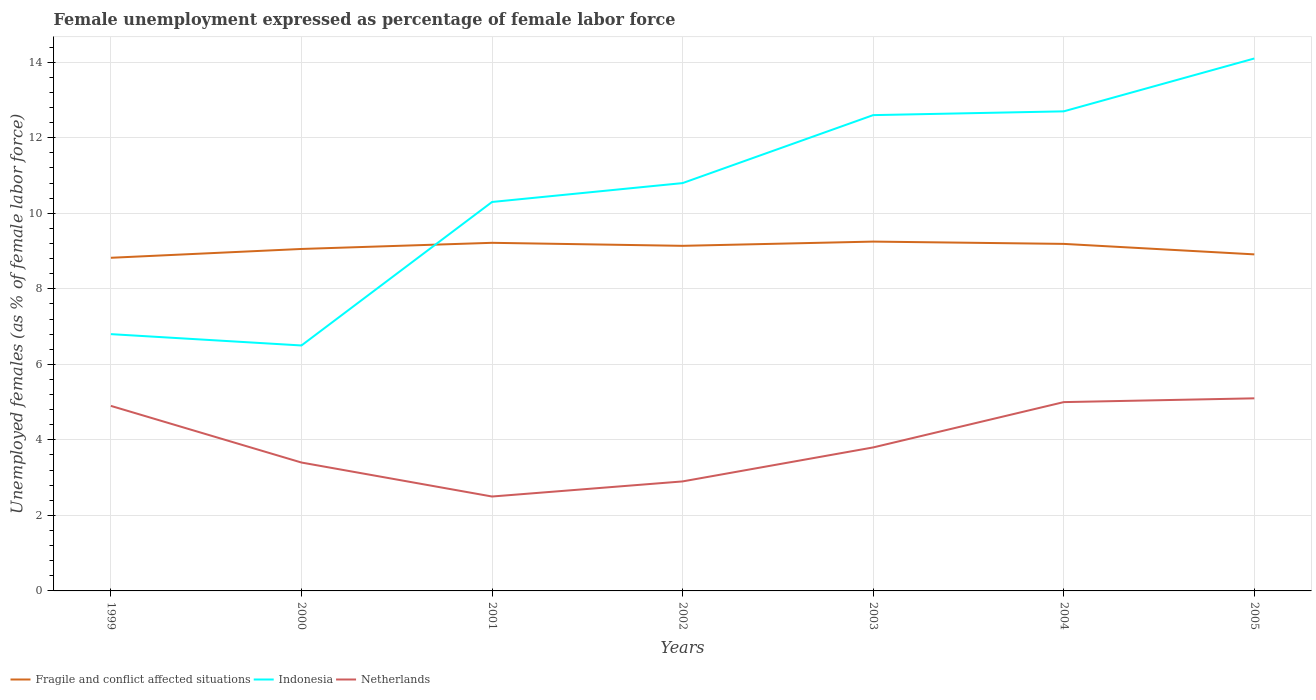How many different coloured lines are there?
Provide a short and direct response. 3. In which year was the unemployment in females in in Netherlands maximum?
Your answer should be compact. 2001. What is the total unemployment in females in in Netherlands in the graph?
Your answer should be compact. -1.3. What is the difference between the highest and the second highest unemployment in females in in Fragile and conflict affected situations?
Keep it short and to the point. 0.43. Is the unemployment in females in in Indonesia strictly greater than the unemployment in females in in Netherlands over the years?
Offer a terse response. No. How many lines are there?
Your answer should be compact. 3. How many years are there in the graph?
Ensure brevity in your answer.  7. What is the difference between two consecutive major ticks on the Y-axis?
Your answer should be compact. 2. Are the values on the major ticks of Y-axis written in scientific E-notation?
Ensure brevity in your answer.  No. Does the graph contain any zero values?
Keep it short and to the point. No. Does the graph contain grids?
Provide a short and direct response. Yes. Where does the legend appear in the graph?
Your response must be concise. Bottom left. How are the legend labels stacked?
Your response must be concise. Horizontal. What is the title of the graph?
Your answer should be very brief. Female unemployment expressed as percentage of female labor force. What is the label or title of the X-axis?
Give a very brief answer. Years. What is the label or title of the Y-axis?
Your answer should be very brief. Unemployed females (as % of female labor force). What is the Unemployed females (as % of female labor force) of Fragile and conflict affected situations in 1999?
Keep it short and to the point. 8.82. What is the Unemployed females (as % of female labor force) in Indonesia in 1999?
Offer a terse response. 6.8. What is the Unemployed females (as % of female labor force) of Netherlands in 1999?
Provide a succinct answer. 4.9. What is the Unemployed females (as % of female labor force) of Fragile and conflict affected situations in 2000?
Provide a short and direct response. 9.06. What is the Unemployed females (as % of female labor force) in Indonesia in 2000?
Offer a terse response. 6.5. What is the Unemployed females (as % of female labor force) of Netherlands in 2000?
Ensure brevity in your answer.  3.4. What is the Unemployed females (as % of female labor force) in Fragile and conflict affected situations in 2001?
Your answer should be compact. 9.22. What is the Unemployed females (as % of female labor force) of Indonesia in 2001?
Offer a terse response. 10.3. What is the Unemployed females (as % of female labor force) in Fragile and conflict affected situations in 2002?
Ensure brevity in your answer.  9.14. What is the Unemployed females (as % of female labor force) in Indonesia in 2002?
Keep it short and to the point. 10.8. What is the Unemployed females (as % of female labor force) of Netherlands in 2002?
Give a very brief answer. 2.9. What is the Unemployed females (as % of female labor force) of Fragile and conflict affected situations in 2003?
Offer a very short reply. 9.25. What is the Unemployed females (as % of female labor force) in Indonesia in 2003?
Keep it short and to the point. 12.6. What is the Unemployed females (as % of female labor force) in Netherlands in 2003?
Offer a very short reply. 3.8. What is the Unemployed females (as % of female labor force) in Fragile and conflict affected situations in 2004?
Make the answer very short. 9.19. What is the Unemployed females (as % of female labor force) of Indonesia in 2004?
Provide a short and direct response. 12.7. What is the Unemployed females (as % of female labor force) in Fragile and conflict affected situations in 2005?
Provide a succinct answer. 8.91. What is the Unemployed females (as % of female labor force) in Indonesia in 2005?
Make the answer very short. 14.1. What is the Unemployed females (as % of female labor force) of Netherlands in 2005?
Ensure brevity in your answer.  5.1. Across all years, what is the maximum Unemployed females (as % of female labor force) of Fragile and conflict affected situations?
Provide a succinct answer. 9.25. Across all years, what is the maximum Unemployed females (as % of female labor force) in Indonesia?
Give a very brief answer. 14.1. Across all years, what is the maximum Unemployed females (as % of female labor force) of Netherlands?
Ensure brevity in your answer.  5.1. Across all years, what is the minimum Unemployed females (as % of female labor force) of Fragile and conflict affected situations?
Offer a terse response. 8.82. Across all years, what is the minimum Unemployed females (as % of female labor force) in Indonesia?
Your answer should be very brief. 6.5. What is the total Unemployed females (as % of female labor force) in Fragile and conflict affected situations in the graph?
Offer a terse response. 63.59. What is the total Unemployed females (as % of female labor force) of Indonesia in the graph?
Make the answer very short. 73.8. What is the total Unemployed females (as % of female labor force) of Netherlands in the graph?
Your answer should be compact. 27.6. What is the difference between the Unemployed females (as % of female labor force) in Fragile and conflict affected situations in 1999 and that in 2000?
Your response must be concise. -0.23. What is the difference between the Unemployed females (as % of female labor force) of Indonesia in 1999 and that in 2000?
Provide a short and direct response. 0.3. What is the difference between the Unemployed females (as % of female labor force) of Netherlands in 1999 and that in 2000?
Keep it short and to the point. 1.5. What is the difference between the Unemployed females (as % of female labor force) in Fragile and conflict affected situations in 1999 and that in 2001?
Offer a very short reply. -0.4. What is the difference between the Unemployed females (as % of female labor force) of Fragile and conflict affected situations in 1999 and that in 2002?
Ensure brevity in your answer.  -0.32. What is the difference between the Unemployed females (as % of female labor force) of Fragile and conflict affected situations in 1999 and that in 2003?
Keep it short and to the point. -0.43. What is the difference between the Unemployed females (as % of female labor force) in Fragile and conflict affected situations in 1999 and that in 2004?
Make the answer very short. -0.37. What is the difference between the Unemployed females (as % of female labor force) of Indonesia in 1999 and that in 2004?
Your answer should be compact. -5.9. What is the difference between the Unemployed females (as % of female labor force) of Fragile and conflict affected situations in 1999 and that in 2005?
Provide a short and direct response. -0.09. What is the difference between the Unemployed females (as % of female labor force) in Indonesia in 1999 and that in 2005?
Give a very brief answer. -7.3. What is the difference between the Unemployed females (as % of female labor force) in Fragile and conflict affected situations in 2000 and that in 2001?
Your answer should be compact. -0.16. What is the difference between the Unemployed females (as % of female labor force) in Netherlands in 2000 and that in 2001?
Offer a terse response. 0.9. What is the difference between the Unemployed females (as % of female labor force) in Fragile and conflict affected situations in 2000 and that in 2002?
Offer a very short reply. -0.08. What is the difference between the Unemployed females (as % of female labor force) in Netherlands in 2000 and that in 2002?
Offer a terse response. 0.5. What is the difference between the Unemployed females (as % of female labor force) of Fragile and conflict affected situations in 2000 and that in 2003?
Offer a terse response. -0.2. What is the difference between the Unemployed females (as % of female labor force) of Indonesia in 2000 and that in 2003?
Ensure brevity in your answer.  -6.1. What is the difference between the Unemployed females (as % of female labor force) of Netherlands in 2000 and that in 2003?
Your response must be concise. -0.4. What is the difference between the Unemployed females (as % of female labor force) in Fragile and conflict affected situations in 2000 and that in 2004?
Keep it short and to the point. -0.13. What is the difference between the Unemployed females (as % of female labor force) in Netherlands in 2000 and that in 2004?
Your response must be concise. -1.6. What is the difference between the Unemployed females (as % of female labor force) in Fragile and conflict affected situations in 2000 and that in 2005?
Keep it short and to the point. 0.14. What is the difference between the Unemployed females (as % of female labor force) in Indonesia in 2000 and that in 2005?
Give a very brief answer. -7.6. What is the difference between the Unemployed females (as % of female labor force) of Netherlands in 2000 and that in 2005?
Your answer should be compact. -1.7. What is the difference between the Unemployed females (as % of female labor force) of Fragile and conflict affected situations in 2001 and that in 2002?
Offer a very short reply. 0.08. What is the difference between the Unemployed females (as % of female labor force) of Fragile and conflict affected situations in 2001 and that in 2003?
Ensure brevity in your answer.  -0.03. What is the difference between the Unemployed females (as % of female labor force) in Indonesia in 2001 and that in 2003?
Provide a short and direct response. -2.3. What is the difference between the Unemployed females (as % of female labor force) in Fragile and conflict affected situations in 2001 and that in 2004?
Your answer should be very brief. 0.03. What is the difference between the Unemployed females (as % of female labor force) in Netherlands in 2001 and that in 2004?
Provide a succinct answer. -2.5. What is the difference between the Unemployed females (as % of female labor force) in Fragile and conflict affected situations in 2001 and that in 2005?
Your answer should be very brief. 0.31. What is the difference between the Unemployed females (as % of female labor force) of Fragile and conflict affected situations in 2002 and that in 2003?
Ensure brevity in your answer.  -0.11. What is the difference between the Unemployed females (as % of female labor force) of Indonesia in 2002 and that in 2003?
Give a very brief answer. -1.8. What is the difference between the Unemployed females (as % of female labor force) in Netherlands in 2002 and that in 2003?
Your answer should be very brief. -0.9. What is the difference between the Unemployed females (as % of female labor force) in Fragile and conflict affected situations in 2002 and that in 2004?
Your answer should be compact. -0.05. What is the difference between the Unemployed females (as % of female labor force) of Fragile and conflict affected situations in 2002 and that in 2005?
Your answer should be compact. 0.23. What is the difference between the Unemployed females (as % of female labor force) of Fragile and conflict affected situations in 2003 and that in 2004?
Offer a very short reply. 0.06. What is the difference between the Unemployed females (as % of female labor force) of Indonesia in 2003 and that in 2004?
Your answer should be very brief. -0.1. What is the difference between the Unemployed females (as % of female labor force) in Netherlands in 2003 and that in 2004?
Provide a short and direct response. -1.2. What is the difference between the Unemployed females (as % of female labor force) of Fragile and conflict affected situations in 2003 and that in 2005?
Your answer should be compact. 0.34. What is the difference between the Unemployed females (as % of female labor force) in Indonesia in 2003 and that in 2005?
Keep it short and to the point. -1.5. What is the difference between the Unemployed females (as % of female labor force) in Netherlands in 2003 and that in 2005?
Offer a terse response. -1.3. What is the difference between the Unemployed females (as % of female labor force) of Fragile and conflict affected situations in 2004 and that in 2005?
Make the answer very short. 0.28. What is the difference between the Unemployed females (as % of female labor force) in Indonesia in 2004 and that in 2005?
Provide a succinct answer. -1.4. What is the difference between the Unemployed females (as % of female labor force) of Netherlands in 2004 and that in 2005?
Your answer should be very brief. -0.1. What is the difference between the Unemployed females (as % of female labor force) of Fragile and conflict affected situations in 1999 and the Unemployed females (as % of female labor force) of Indonesia in 2000?
Ensure brevity in your answer.  2.32. What is the difference between the Unemployed females (as % of female labor force) of Fragile and conflict affected situations in 1999 and the Unemployed females (as % of female labor force) of Netherlands in 2000?
Make the answer very short. 5.42. What is the difference between the Unemployed females (as % of female labor force) in Fragile and conflict affected situations in 1999 and the Unemployed females (as % of female labor force) in Indonesia in 2001?
Make the answer very short. -1.48. What is the difference between the Unemployed females (as % of female labor force) of Fragile and conflict affected situations in 1999 and the Unemployed females (as % of female labor force) of Netherlands in 2001?
Your answer should be very brief. 6.32. What is the difference between the Unemployed females (as % of female labor force) in Indonesia in 1999 and the Unemployed females (as % of female labor force) in Netherlands in 2001?
Give a very brief answer. 4.3. What is the difference between the Unemployed females (as % of female labor force) of Fragile and conflict affected situations in 1999 and the Unemployed females (as % of female labor force) of Indonesia in 2002?
Provide a succinct answer. -1.98. What is the difference between the Unemployed females (as % of female labor force) of Fragile and conflict affected situations in 1999 and the Unemployed females (as % of female labor force) of Netherlands in 2002?
Your response must be concise. 5.92. What is the difference between the Unemployed females (as % of female labor force) in Indonesia in 1999 and the Unemployed females (as % of female labor force) in Netherlands in 2002?
Offer a terse response. 3.9. What is the difference between the Unemployed females (as % of female labor force) in Fragile and conflict affected situations in 1999 and the Unemployed females (as % of female labor force) in Indonesia in 2003?
Your answer should be compact. -3.78. What is the difference between the Unemployed females (as % of female labor force) of Fragile and conflict affected situations in 1999 and the Unemployed females (as % of female labor force) of Netherlands in 2003?
Make the answer very short. 5.02. What is the difference between the Unemployed females (as % of female labor force) in Indonesia in 1999 and the Unemployed females (as % of female labor force) in Netherlands in 2003?
Offer a terse response. 3. What is the difference between the Unemployed females (as % of female labor force) of Fragile and conflict affected situations in 1999 and the Unemployed females (as % of female labor force) of Indonesia in 2004?
Offer a terse response. -3.88. What is the difference between the Unemployed females (as % of female labor force) of Fragile and conflict affected situations in 1999 and the Unemployed females (as % of female labor force) of Netherlands in 2004?
Keep it short and to the point. 3.82. What is the difference between the Unemployed females (as % of female labor force) in Indonesia in 1999 and the Unemployed females (as % of female labor force) in Netherlands in 2004?
Give a very brief answer. 1.8. What is the difference between the Unemployed females (as % of female labor force) of Fragile and conflict affected situations in 1999 and the Unemployed females (as % of female labor force) of Indonesia in 2005?
Keep it short and to the point. -5.28. What is the difference between the Unemployed females (as % of female labor force) of Fragile and conflict affected situations in 1999 and the Unemployed females (as % of female labor force) of Netherlands in 2005?
Your answer should be very brief. 3.72. What is the difference between the Unemployed females (as % of female labor force) of Fragile and conflict affected situations in 2000 and the Unemployed females (as % of female labor force) of Indonesia in 2001?
Offer a very short reply. -1.24. What is the difference between the Unemployed females (as % of female labor force) in Fragile and conflict affected situations in 2000 and the Unemployed females (as % of female labor force) in Netherlands in 2001?
Offer a very short reply. 6.56. What is the difference between the Unemployed females (as % of female labor force) of Indonesia in 2000 and the Unemployed females (as % of female labor force) of Netherlands in 2001?
Your response must be concise. 4. What is the difference between the Unemployed females (as % of female labor force) in Fragile and conflict affected situations in 2000 and the Unemployed females (as % of female labor force) in Indonesia in 2002?
Give a very brief answer. -1.74. What is the difference between the Unemployed females (as % of female labor force) of Fragile and conflict affected situations in 2000 and the Unemployed females (as % of female labor force) of Netherlands in 2002?
Provide a short and direct response. 6.16. What is the difference between the Unemployed females (as % of female labor force) of Fragile and conflict affected situations in 2000 and the Unemployed females (as % of female labor force) of Indonesia in 2003?
Your answer should be very brief. -3.54. What is the difference between the Unemployed females (as % of female labor force) in Fragile and conflict affected situations in 2000 and the Unemployed females (as % of female labor force) in Netherlands in 2003?
Give a very brief answer. 5.26. What is the difference between the Unemployed females (as % of female labor force) in Indonesia in 2000 and the Unemployed females (as % of female labor force) in Netherlands in 2003?
Keep it short and to the point. 2.7. What is the difference between the Unemployed females (as % of female labor force) of Fragile and conflict affected situations in 2000 and the Unemployed females (as % of female labor force) of Indonesia in 2004?
Your answer should be very brief. -3.64. What is the difference between the Unemployed females (as % of female labor force) of Fragile and conflict affected situations in 2000 and the Unemployed females (as % of female labor force) of Netherlands in 2004?
Your answer should be compact. 4.06. What is the difference between the Unemployed females (as % of female labor force) in Indonesia in 2000 and the Unemployed females (as % of female labor force) in Netherlands in 2004?
Provide a short and direct response. 1.5. What is the difference between the Unemployed females (as % of female labor force) in Fragile and conflict affected situations in 2000 and the Unemployed females (as % of female labor force) in Indonesia in 2005?
Ensure brevity in your answer.  -5.04. What is the difference between the Unemployed females (as % of female labor force) in Fragile and conflict affected situations in 2000 and the Unemployed females (as % of female labor force) in Netherlands in 2005?
Your response must be concise. 3.96. What is the difference between the Unemployed females (as % of female labor force) in Indonesia in 2000 and the Unemployed females (as % of female labor force) in Netherlands in 2005?
Provide a short and direct response. 1.4. What is the difference between the Unemployed females (as % of female labor force) in Fragile and conflict affected situations in 2001 and the Unemployed females (as % of female labor force) in Indonesia in 2002?
Ensure brevity in your answer.  -1.58. What is the difference between the Unemployed females (as % of female labor force) in Fragile and conflict affected situations in 2001 and the Unemployed females (as % of female labor force) in Netherlands in 2002?
Offer a terse response. 6.32. What is the difference between the Unemployed females (as % of female labor force) of Indonesia in 2001 and the Unemployed females (as % of female labor force) of Netherlands in 2002?
Offer a terse response. 7.4. What is the difference between the Unemployed females (as % of female labor force) of Fragile and conflict affected situations in 2001 and the Unemployed females (as % of female labor force) of Indonesia in 2003?
Your response must be concise. -3.38. What is the difference between the Unemployed females (as % of female labor force) of Fragile and conflict affected situations in 2001 and the Unemployed females (as % of female labor force) of Netherlands in 2003?
Offer a very short reply. 5.42. What is the difference between the Unemployed females (as % of female labor force) in Fragile and conflict affected situations in 2001 and the Unemployed females (as % of female labor force) in Indonesia in 2004?
Offer a very short reply. -3.48. What is the difference between the Unemployed females (as % of female labor force) of Fragile and conflict affected situations in 2001 and the Unemployed females (as % of female labor force) of Netherlands in 2004?
Make the answer very short. 4.22. What is the difference between the Unemployed females (as % of female labor force) of Indonesia in 2001 and the Unemployed females (as % of female labor force) of Netherlands in 2004?
Offer a very short reply. 5.3. What is the difference between the Unemployed females (as % of female labor force) of Fragile and conflict affected situations in 2001 and the Unemployed females (as % of female labor force) of Indonesia in 2005?
Offer a terse response. -4.88. What is the difference between the Unemployed females (as % of female labor force) in Fragile and conflict affected situations in 2001 and the Unemployed females (as % of female labor force) in Netherlands in 2005?
Give a very brief answer. 4.12. What is the difference between the Unemployed females (as % of female labor force) in Indonesia in 2001 and the Unemployed females (as % of female labor force) in Netherlands in 2005?
Your response must be concise. 5.2. What is the difference between the Unemployed females (as % of female labor force) in Fragile and conflict affected situations in 2002 and the Unemployed females (as % of female labor force) in Indonesia in 2003?
Your answer should be very brief. -3.46. What is the difference between the Unemployed females (as % of female labor force) of Fragile and conflict affected situations in 2002 and the Unemployed females (as % of female labor force) of Netherlands in 2003?
Give a very brief answer. 5.34. What is the difference between the Unemployed females (as % of female labor force) in Indonesia in 2002 and the Unemployed females (as % of female labor force) in Netherlands in 2003?
Provide a short and direct response. 7. What is the difference between the Unemployed females (as % of female labor force) in Fragile and conflict affected situations in 2002 and the Unemployed females (as % of female labor force) in Indonesia in 2004?
Keep it short and to the point. -3.56. What is the difference between the Unemployed females (as % of female labor force) in Fragile and conflict affected situations in 2002 and the Unemployed females (as % of female labor force) in Netherlands in 2004?
Your answer should be very brief. 4.14. What is the difference between the Unemployed females (as % of female labor force) of Fragile and conflict affected situations in 2002 and the Unemployed females (as % of female labor force) of Indonesia in 2005?
Make the answer very short. -4.96. What is the difference between the Unemployed females (as % of female labor force) of Fragile and conflict affected situations in 2002 and the Unemployed females (as % of female labor force) of Netherlands in 2005?
Give a very brief answer. 4.04. What is the difference between the Unemployed females (as % of female labor force) in Indonesia in 2002 and the Unemployed females (as % of female labor force) in Netherlands in 2005?
Your response must be concise. 5.7. What is the difference between the Unemployed females (as % of female labor force) of Fragile and conflict affected situations in 2003 and the Unemployed females (as % of female labor force) of Indonesia in 2004?
Keep it short and to the point. -3.45. What is the difference between the Unemployed females (as % of female labor force) in Fragile and conflict affected situations in 2003 and the Unemployed females (as % of female labor force) in Netherlands in 2004?
Keep it short and to the point. 4.25. What is the difference between the Unemployed females (as % of female labor force) in Indonesia in 2003 and the Unemployed females (as % of female labor force) in Netherlands in 2004?
Keep it short and to the point. 7.6. What is the difference between the Unemployed females (as % of female labor force) in Fragile and conflict affected situations in 2003 and the Unemployed females (as % of female labor force) in Indonesia in 2005?
Offer a very short reply. -4.85. What is the difference between the Unemployed females (as % of female labor force) in Fragile and conflict affected situations in 2003 and the Unemployed females (as % of female labor force) in Netherlands in 2005?
Your answer should be very brief. 4.15. What is the difference between the Unemployed females (as % of female labor force) of Fragile and conflict affected situations in 2004 and the Unemployed females (as % of female labor force) of Indonesia in 2005?
Provide a succinct answer. -4.91. What is the difference between the Unemployed females (as % of female labor force) in Fragile and conflict affected situations in 2004 and the Unemployed females (as % of female labor force) in Netherlands in 2005?
Ensure brevity in your answer.  4.09. What is the average Unemployed females (as % of female labor force) in Fragile and conflict affected situations per year?
Keep it short and to the point. 9.08. What is the average Unemployed females (as % of female labor force) in Indonesia per year?
Make the answer very short. 10.54. What is the average Unemployed females (as % of female labor force) in Netherlands per year?
Your answer should be compact. 3.94. In the year 1999, what is the difference between the Unemployed females (as % of female labor force) of Fragile and conflict affected situations and Unemployed females (as % of female labor force) of Indonesia?
Ensure brevity in your answer.  2.02. In the year 1999, what is the difference between the Unemployed females (as % of female labor force) of Fragile and conflict affected situations and Unemployed females (as % of female labor force) of Netherlands?
Provide a succinct answer. 3.92. In the year 1999, what is the difference between the Unemployed females (as % of female labor force) in Indonesia and Unemployed females (as % of female labor force) in Netherlands?
Give a very brief answer. 1.9. In the year 2000, what is the difference between the Unemployed females (as % of female labor force) in Fragile and conflict affected situations and Unemployed females (as % of female labor force) in Indonesia?
Provide a short and direct response. 2.56. In the year 2000, what is the difference between the Unemployed females (as % of female labor force) of Fragile and conflict affected situations and Unemployed females (as % of female labor force) of Netherlands?
Offer a terse response. 5.66. In the year 2000, what is the difference between the Unemployed females (as % of female labor force) of Indonesia and Unemployed females (as % of female labor force) of Netherlands?
Provide a short and direct response. 3.1. In the year 2001, what is the difference between the Unemployed females (as % of female labor force) of Fragile and conflict affected situations and Unemployed females (as % of female labor force) of Indonesia?
Provide a short and direct response. -1.08. In the year 2001, what is the difference between the Unemployed females (as % of female labor force) in Fragile and conflict affected situations and Unemployed females (as % of female labor force) in Netherlands?
Your response must be concise. 6.72. In the year 2001, what is the difference between the Unemployed females (as % of female labor force) in Indonesia and Unemployed females (as % of female labor force) in Netherlands?
Give a very brief answer. 7.8. In the year 2002, what is the difference between the Unemployed females (as % of female labor force) in Fragile and conflict affected situations and Unemployed females (as % of female labor force) in Indonesia?
Your response must be concise. -1.66. In the year 2002, what is the difference between the Unemployed females (as % of female labor force) in Fragile and conflict affected situations and Unemployed females (as % of female labor force) in Netherlands?
Provide a short and direct response. 6.24. In the year 2002, what is the difference between the Unemployed females (as % of female labor force) in Indonesia and Unemployed females (as % of female labor force) in Netherlands?
Ensure brevity in your answer.  7.9. In the year 2003, what is the difference between the Unemployed females (as % of female labor force) of Fragile and conflict affected situations and Unemployed females (as % of female labor force) of Indonesia?
Your answer should be compact. -3.35. In the year 2003, what is the difference between the Unemployed females (as % of female labor force) of Fragile and conflict affected situations and Unemployed females (as % of female labor force) of Netherlands?
Provide a short and direct response. 5.45. In the year 2004, what is the difference between the Unemployed females (as % of female labor force) in Fragile and conflict affected situations and Unemployed females (as % of female labor force) in Indonesia?
Offer a terse response. -3.51. In the year 2004, what is the difference between the Unemployed females (as % of female labor force) in Fragile and conflict affected situations and Unemployed females (as % of female labor force) in Netherlands?
Give a very brief answer. 4.19. In the year 2005, what is the difference between the Unemployed females (as % of female labor force) of Fragile and conflict affected situations and Unemployed females (as % of female labor force) of Indonesia?
Provide a short and direct response. -5.19. In the year 2005, what is the difference between the Unemployed females (as % of female labor force) in Fragile and conflict affected situations and Unemployed females (as % of female labor force) in Netherlands?
Your answer should be very brief. 3.81. What is the ratio of the Unemployed females (as % of female labor force) of Fragile and conflict affected situations in 1999 to that in 2000?
Make the answer very short. 0.97. What is the ratio of the Unemployed females (as % of female labor force) in Indonesia in 1999 to that in 2000?
Your answer should be very brief. 1.05. What is the ratio of the Unemployed females (as % of female labor force) in Netherlands in 1999 to that in 2000?
Keep it short and to the point. 1.44. What is the ratio of the Unemployed females (as % of female labor force) of Fragile and conflict affected situations in 1999 to that in 2001?
Make the answer very short. 0.96. What is the ratio of the Unemployed females (as % of female labor force) of Indonesia in 1999 to that in 2001?
Offer a terse response. 0.66. What is the ratio of the Unemployed females (as % of female labor force) of Netherlands in 1999 to that in 2001?
Make the answer very short. 1.96. What is the ratio of the Unemployed females (as % of female labor force) in Fragile and conflict affected situations in 1999 to that in 2002?
Provide a short and direct response. 0.97. What is the ratio of the Unemployed females (as % of female labor force) of Indonesia in 1999 to that in 2002?
Offer a terse response. 0.63. What is the ratio of the Unemployed females (as % of female labor force) of Netherlands in 1999 to that in 2002?
Your response must be concise. 1.69. What is the ratio of the Unemployed females (as % of female labor force) of Fragile and conflict affected situations in 1999 to that in 2003?
Make the answer very short. 0.95. What is the ratio of the Unemployed females (as % of female labor force) of Indonesia in 1999 to that in 2003?
Your answer should be very brief. 0.54. What is the ratio of the Unemployed females (as % of female labor force) of Netherlands in 1999 to that in 2003?
Ensure brevity in your answer.  1.29. What is the ratio of the Unemployed females (as % of female labor force) in Fragile and conflict affected situations in 1999 to that in 2004?
Offer a terse response. 0.96. What is the ratio of the Unemployed females (as % of female labor force) of Indonesia in 1999 to that in 2004?
Your response must be concise. 0.54. What is the ratio of the Unemployed females (as % of female labor force) of Fragile and conflict affected situations in 1999 to that in 2005?
Provide a short and direct response. 0.99. What is the ratio of the Unemployed females (as % of female labor force) of Indonesia in 1999 to that in 2005?
Give a very brief answer. 0.48. What is the ratio of the Unemployed females (as % of female labor force) in Netherlands in 1999 to that in 2005?
Give a very brief answer. 0.96. What is the ratio of the Unemployed females (as % of female labor force) of Fragile and conflict affected situations in 2000 to that in 2001?
Your answer should be very brief. 0.98. What is the ratio of the Unemployed females (as % of female labor force) of Indonesia in 2000 to that in 2001?
Your response must be concise. 0.63. What is the ratio of the Unemployed females (as % of female labor force) in Netherlands in 2000 to that in 2001?
Your answer should be very brief. 1.36. What is the ratio of the Unemployed females (as % of female labor force) of Fragile and conflict affected situations in 2000 to that in 2002?
Your answer should be very brief. 0.99. What is the ratio of the Unemployed females (as % of female labor force) in Indonesia in 2000 to that in 2002?
Your answer should be compact. 0.6. What is the ratio of the Unemployed females (as % of female labor force) in Netherlands in 2000 to that in 2002?
Your response must be concise. 1.17. What is the ratio of the Unemployed females (as % of female labor force) in Fragile and conflict affected situations in 2000 to that in 2003?
Ensure brevity in your answer.  0.98. What is the ratio of the Unemployed females (as % of female labor force) in Indonesia in 2000 to that in 2003?
Your answer should be very brief. 0.52. What is the ratio of the Unemployed females (as % of female labor force) of Netherlands in 2000 to that in 2003?
Give a very brief answer. 0.89. What is the ratio of the Unemployed females (as % of female labor force) of Fragile and conflict affected situations in 2000 to that in 2004?
Offer a terse response. 0.99. What is the ratio of the Unemployed females (as % of female labor force) of Indonesia in 2000 to that in 2004?
Your response must be concise. 0.51. What is the ratio of the Unemployed females (as % of female labor force) in Netherlands in 2000 to that in 2004?
Give a very brief answer. 0.68. What is the ratio of the Unemployed females (as % of female labor force) of Fragile and conflict affected situations in 2000 to that in 2005?
Offer a terse response. 1.02. What is the ratio of the Unemployed females (as % of female labor force) of Indonesia in 2000 to that in 2005?
Your answer should be very brief. 0.46. What is the ratio of the Unemployed females (as % of female labor force) of Fragile and conflict affected situations in 2001 to that in 2002?
Keep it short and to the point. 1.01. What is the ratio of the Unemployed females (as % of female labor force) in Indonesia in 2001 to that in 2002?
Provide a short and direct response. 0.95. What is the ratio of the Unemployed females (as % of female labor force) in Netherlands in 2001 to that in 2002?
Your answer should be compact. 0.86. What is the ratio of the Unemployed females (as % of female labor force) in Indonesia in 2001 to that in 2003?
Your answer should be very brief. 0.82. What is the ratio of the Unemployed females (as % of female labor force) of Netherlands in 2001 to that in 2003?
Provide a succinct answer. 0.66. What is the ratio of the Unemployed females (as % of female labor force) in Fragile and conflict affected situations in 2001 to that in 2004?
Offer a terse response. 1. What is the ratio of the Unemployed females (as % of female labor force) of Indonesia in 2001 to that in 2004?
Provide a succinct answer. 0.81. What is the ratio of the Unemployed females (as % of female labor force) of Netherlands in 2001 to that in 2004?
Keep it short and to the point. 0.5. What is the ratio of the Unemployed females (as % of female labor force) in Fragile and conflict affected situations in 2001 to that in 2005?
Keep it short and to the point. 1.03. What is the ratio of the Unemployed females (as % of female labor force) in Indonesia in 2001 to that in 2005?
Ensure brevity in your answer.  0.73. What is the ratio of the Unemployed females (as % of female labor force) of Netherlands in 2001 to that in 2005?
Give a very brief answer. 0.49. What is the ratio of the Unemployed females (as % of female labor force) in Fragile and conflict affected situations in 2002 to that in 2003?
Provide a succinct answer. 0.99. What is the ratio of the Unemployed females (as % of female labor force) in Netherlands in 2002 to that in 2003?
Offer a terse response. 0.76. What is the ratio of the Unemployed females (as % of female labor force) in Fragile and conflict affected situations in 2002 to that in 2004?
Provide a succinct answer. 0.99. What is the ratio of the Unemployed females (as % of female labor force) in Indonesia in 2002 to that in 2004?
Your answer should be compact. 0.85. What is the ratio of the Unemployed females (as % of female labor force) in Netherlands in 2002 to that in 2004?
Your answer should be compact. 0.58. What is the ratio of the Unemployed females (as % of female labor force) of Fragile and conflict affected situations in 2002 to that in 2005?
Keep it short and to the point. 1.03. What is the ratio of the Unemployed females (as % of female labor force) in Indonesia in 2002 to that in 2005?
Offer a very short reply. 0.77. What is the ratio of the Unemployed females (as % of female labor force) of Netherlands in 2002 to that in 2005?
Your answer should be compact. 0.57. What is the ratio of the Unemployed females (as % of female labor force) of Fragile and conflict affected situations in 2003 to that in 2004?
Provide a short and direct response. 1.01. What is the ratio of the Unemployed females (as % of female labor force) of Indonesia in 2003 to that in 2004?
Ensure brevity in your answer.  0.99. What is the ratio of the Unemployed females (as % of female labor force) in Netherlands in 2003 to that in 2004?
Your answer should be compact. 0.76. What is the ratio of the Unemployed females (as % of female labor force) in Fragile and conflict affected situations in 2003 to that in 2005?
Ensure brevity in your answer.  1.04. What is the ratio of the Unemployed females (as % of female labor force) in Indonesia in 2003 to that in 2005?
Provide a succinct answer. 0.89. What is the ratio of the Unemployed females (as % of female labor force) of Netherlands in 2003 to that in 2005?
Give a very brief answer. 0.75. What is the ratio of the Unemployed females (as % of female labor force) in Fragile and conflict affected situations in 2004 to that in 2005?
Your response must be concise. 1.03. What is the ratio of the Unemployed females (as % of female labor force) of Indonesia in 2004 to that in 2005?
Ensure brevity in your answer.  0.9. What is the ratio of the Unemployed females (as % of female labor force) of Netherlands in 2004 to that in 2005?
Ensure brevity in your answer.  0.98. What is the difference between the highest and the second highest Unemployed females (as % of female labor force) of Fragile and conflict affected situations?
Make the answer very short. 0.03. What is the difference between the highest and the lowest Unemployed females (as % of female labor force) of Fragile and conflict affected situations?
Provide a short and direct response. 0.43. What is the difference between the highest and the lowest Unemployed females (as % of female labor force) of Netherlands?
Offer a terse response. 2.6. 